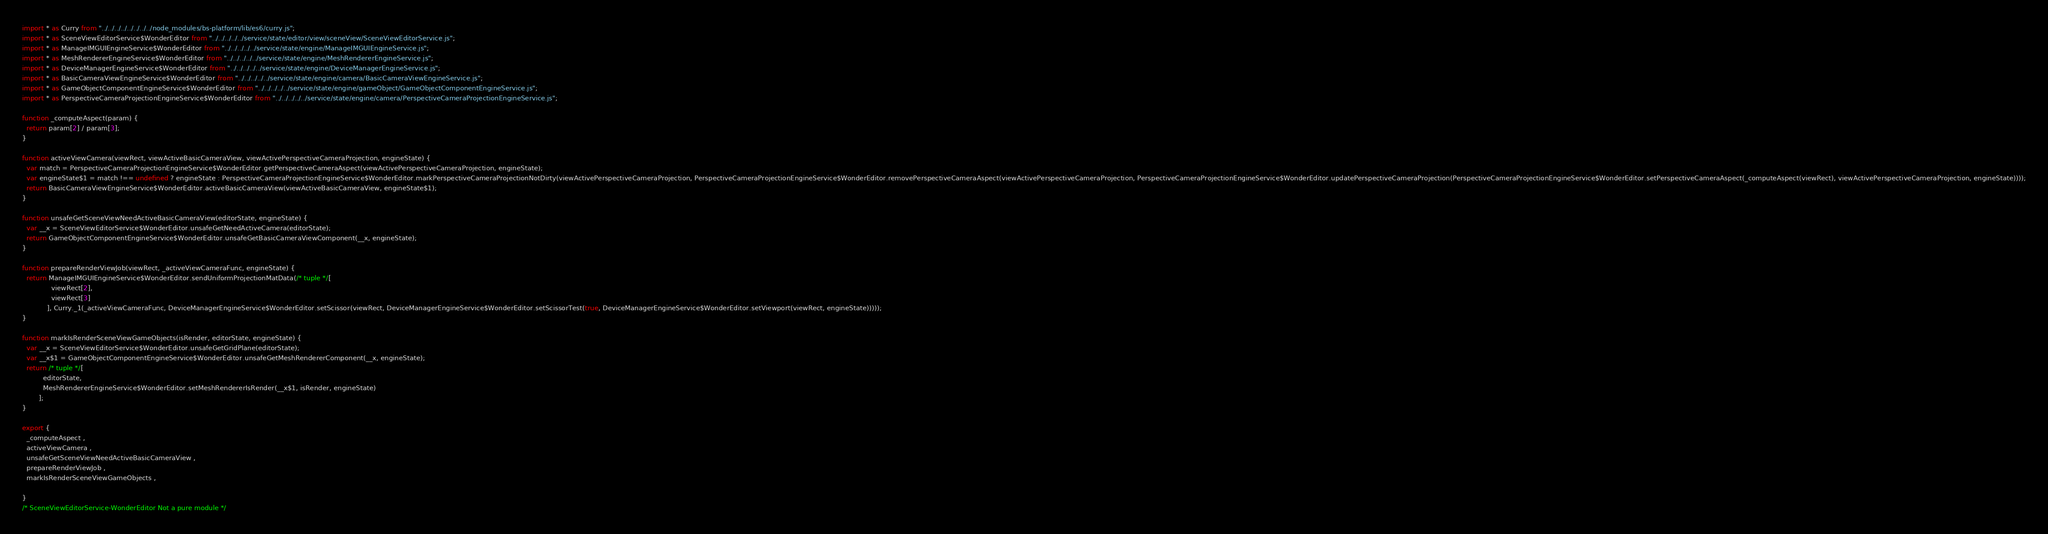<code> <loc_0><loc_0><loc_500><loc_500><_JavaScript_>

import * as Curry from "../../../../../../../../node_modules/bs-platform/lib/es6/curry.js";
import * as SceneViewEditorService$WonderEditor from "../../../../../service/state/editor/view/sceneView/SceneViewEditorService.js";
import * as ManageIMGUIEngineService$WonderEditor from "../../../../../service/state/engine/ManageIMGUIEngineService.js";
import * as MeshRendererEngineService$WonderEditor from "../../../../../service/state/engine/MeshRendererEngineService.js";
import * as DeviceManagerEngineService$WonderEditor from "../../../../../service/state/engine/DeviceManagerEngineService.js";
import * as BasicCameraViewEngineService$WonderEditor from "../../../../../service/state/engine/camera/BasicCameraViewEngineService.js";
import * as GameObjectComponentEngineService$WonderEditor from "../../../../../service/state/engine/gameObject/GameObjectComponentEngineService.js";
import * as PerspectiveCameraProjectionEngineService$WonderEditor from "../../../../../service/state/engine/camera/PerspectiveCameraProjectionEngineService.js";

function _computeAspect(param) {
  return param[2] / param[3];
}

function activeViewCamera(viewRect, viewActiveBasicCameraView, viewActivePerspectiveCameraProjection, engineState) {
  var match = PerspectiveCameraProjectionEngineService$WonderEditor.getPerspectiveCameraAspect(viewActivePerspectiveCameraProjection, engineState);
  var engineState$1 = match !== undefined ? engineState : PerspectiveCameraProjectionEngineService$WonderEditor.markPerspectiveCameraProjectionNotDirty(viewActivePerspectiveCameraProjection, PerspectiveCameraProjectionEngineService$WonderEditor.removePerspectiveCameraAspect(viewActivePerspectiveCameraProjection, PerspectiveCameraProjectionEngineService$WonderEditor.updatePerspectiveCameraProjection(PerspectiveCameraProjectionEngineService$WonderEditor.setPerspectiveCameraAspect(_computeAspect(viewRect), viewActivePerspectiveCameraProjection, engineState))));
  return BasicCameraViewEngineService$WonderEditor.activeBasicCameraView(viewActiveBasicCameraView, engineState$1);
}

function unsafeGetSceneViewNeedActiveBasicCameraView(editorState, engineState) {
  var __x = SceneViewEditorService$WonderEditor.unsafeGetNeedActiveCamera(editorState);
  return GameObjectComponentEngineService$WonderEditor.unsafeGetBasicCameraViewComponent(__x, engineState);
}

function prepareRenderViewJob(viewRect, _activeViewCameraFunc, engineState) {
  return ManageIMGUIEngineService$WonderEditor.sendUniformProjectionMatData(/* tuple */[
              viewRect[2],
              viewRect[3]
            ], Curry._1(_activeViewCameraFunc, DeviceManagerEngineService$WonderEditor.setScissor(viewRect, DeviceManagerEngineService$WonderEditor.setScissorTest(true, DeviceManagerEngineService$WonderEditor.setViewport(viewRect, engineState)))));
}

function markIsRenderSceneViewGameObjects(isRender, editorState, engineState) {
  var __x = SceneViewEditorService$WonderEditor.unsafeGetGridPlane(editorState);
  var __x$1 = GameObjectComponentEngineService$WonderEditor.unsafeGetMeshRendererComponent(__x, engineState);
  return /* tuple */[
          editorState,
          MeshRendererEngineService$WonderEditor.setMeshRendererIsRender(__x$1, isRender, engineState)
        ];
}

export {
  _computeAspect ,
  activeViewCamera ,
  unsafeGetSceneViewNeedActiveBasicCameraView ,
  prepareRenderViewJob ,
  markIsRenderSceneViewGameObjects ,
  
}
/* SceneViewEditorService-WonderEditor Not a pure module */
</code> 